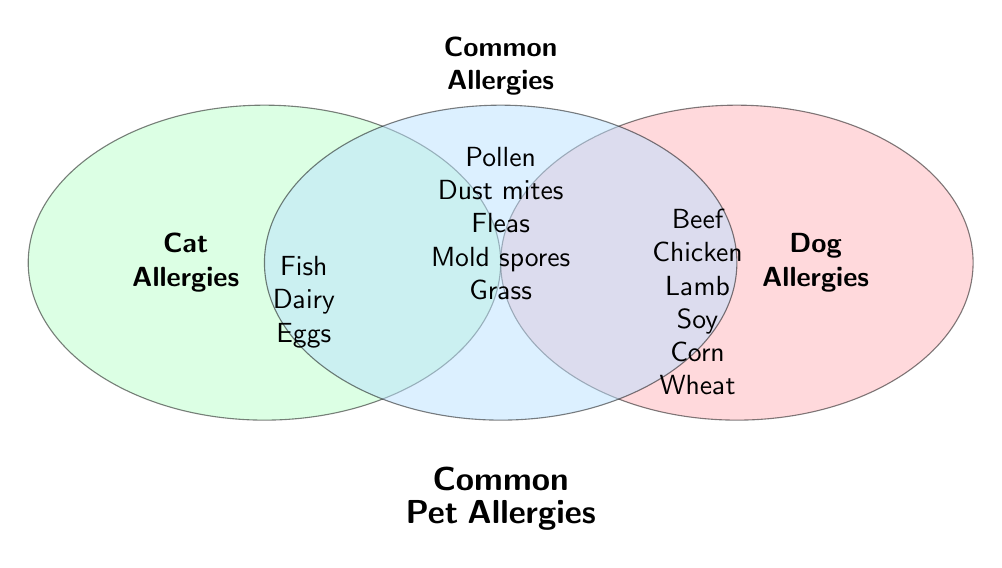Which allergens are common to both dogs and cats? Look at the section of the Venn diagram where all three circles overlap. The text there lists common allergens.
Answer: Pollen, Dust mites, Fleas, Mold spores, Grass What allergens are specific to dogs only? Check the section of the Venn diagram that is part of the "Dog Allergies" circle but does not overlap with the "Cat Allergies" circle.
Answer: Beef, Chicken, Lamb, Soy, Corn, Wheat What allergens are unique to cats? Look at the section of the Venn diagram that is part of the "Cat Allergies" circle but does not overlap with the "Dog Allergies" circle.
Answer: Fish, Dairy, Eggs How many allergens are common between dogs and cats? Count the number of items listed in the common or overlapping section of the Venn diagram.
Answer: 5 Which allergens overlap between dogs, cats, and any common section? Look at the entire areas of overlap in the Venn diagram and combine the lists from each section where there is an overlap.
Answer: None outside of the provided common allergens (Pollen, Dust mites, Fleas, Mold spores, Grass) How many allergens are there in total for dogs? Count the unique allergens listed in the "Dog Allergies" section and add the ones in the common section.
Answer: 11 What is the difference between the number of unique dog allergens and unique cat allergens? Calculate the number of unique allergens for dogs (6) and cats (3), then find the difference.
Answer: 3 Which overlap section contains allergens like Fish and Dairy? Look in the "Cat Allergies" section since these are listed as unique to cats and not in any overlap.
Answer: Cat Allergies Which section contains allergens such as Dust mites and Mold spores? Find these allergens in the common section where the circles overlap.
Answer: Common allergies Are there any allergens listed that only dogs are affected by that are not in the common section or cat section? Check the "Dog Allergies" circle for allergens not listed in the common or cat sections.
Answer: Corn, Soy, Chicken, Wheat, Lamb 